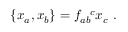Convert formula to latex. <formula><loc_0><loc_0><loc_500><loc_500>\{ x _ { a } , x _ { b } \} = f _ { a b } ^ { c } x _ { c } .</formula> 